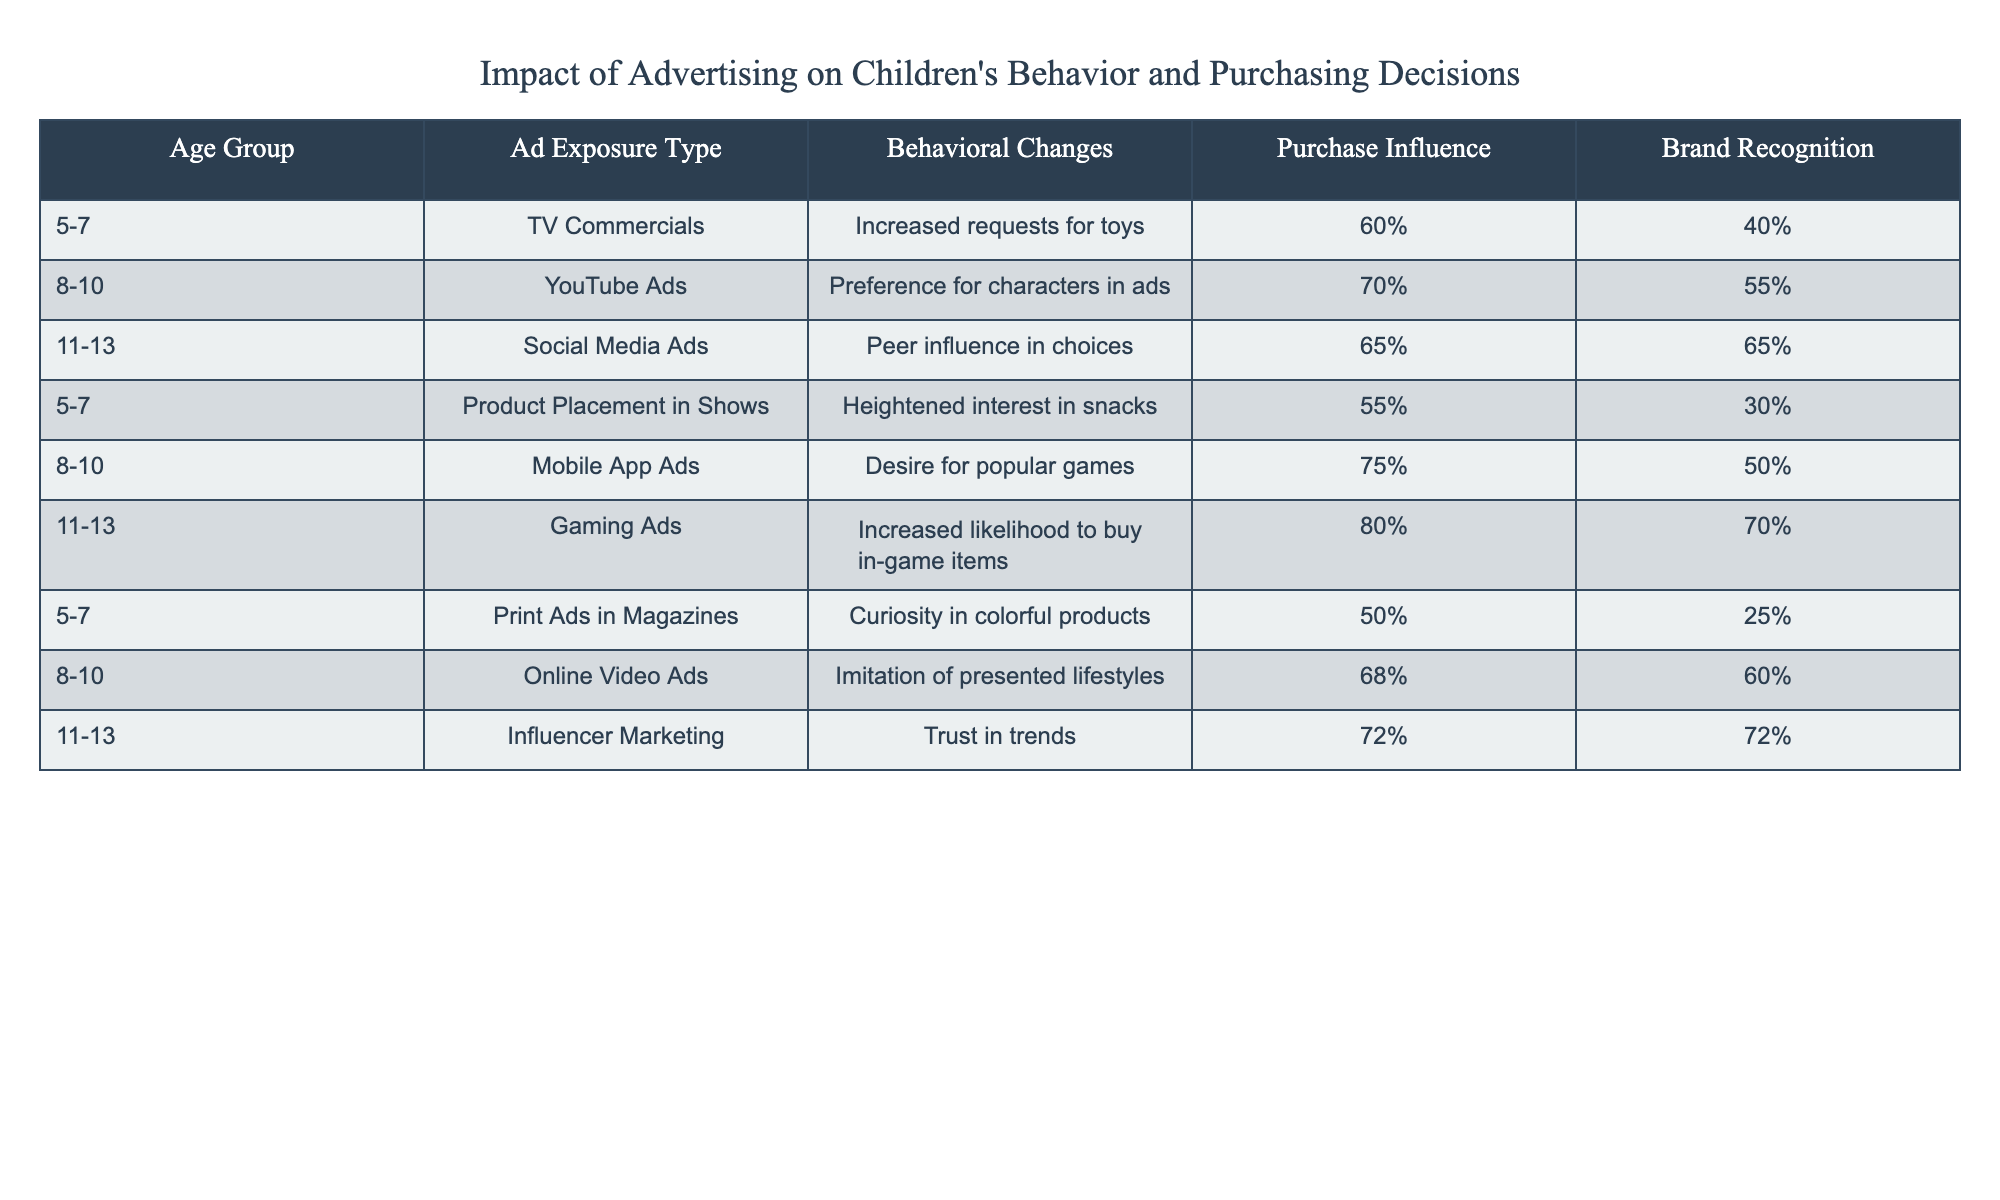What is the behavioral change reported for the 5-7 age group exposed to TV commercials? The table indicates that the behavioral change for the 5-7 age group exposed to TV commercials is "Increased requests for toys." This information is found directly in the row associated with the 5-7 age group and the TV Commercials exposure type.
Answer: Increased requests for toys Which age group shows the highest percentage of purchase influence from mobile app ads? By looking at the table, the age group of 8-10 shows a purchase influence of 50% from mobile app ads. This is the highest percentage for that ad exposure type, as other age groups have lower values.
Answer: 50% What is the difference in brand recognition between the 8-10 age group and the 11-13 age group exposed to influencer marketing? For the 8-10 age group, brand recognition is 0% since influencer marketing does not appear for that group. For the 11-13 age group, brand recognition is 72%. The difference is calculated as 72% - 0% = 72%.
Answer: 72% Are TV commercials effective in heightening interest in snacks for children aged 5-7? The table shows that for the 5-7 age group, the exposure type "Product Placement in Shows" heightened interest in snacks, rather than TV commercials. Therefore, the effectiveness of TV commercials for this specific behavior change is not supported by the data.
Answer: No What age group has the highest likelihood to buy in-game items due to gaming ads? By inspecting the table, the age group of 11-13 has a likelihood of 80% to buy in-game items due to gaming ads. This is indeed the highest percentage for that specific exposure type when compared to other age groups.
Answer: 80% How does the average purchase influence for the 8-10 age group compare with that of the 5-7 age group? For the 8-10 age group, the purchase influences from YouTube Ads and Mobile App Ads are 55% and 50% respectively. By averaging these two (55% + 50% = 105% / 2 = 52.5%). For the 5-7 age group, average purchase influence across different ad types (40%, 30%, 25%) is (40% + 30% + 25%) / 3 = 31.67%. Comparing both: 52.5% > 31.67%.
Answer: 52.5% is higher Is there any ad exposure type that influences brand recognition equally across all age groups? Looking through the table data, each ad exposure type shows differing levels of brand recognition among the age groups. No exposure type demonstrates equal brand recognition across all age groups; therefore, the answer is negative.
Answer: No 